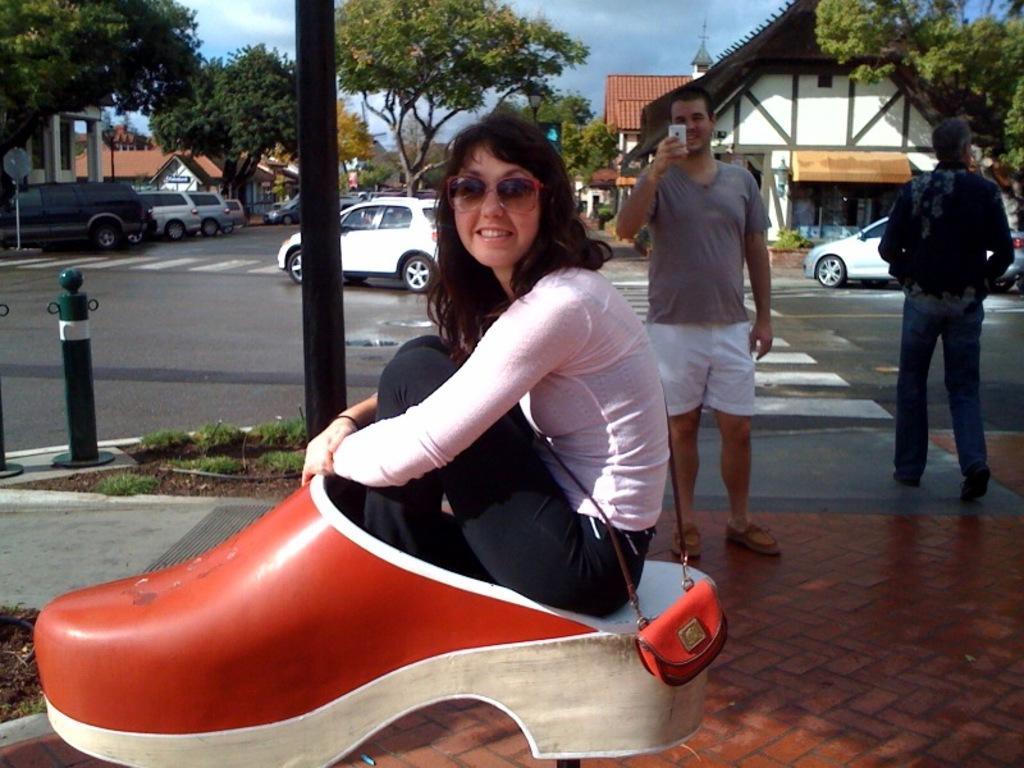In one or two sentences, can you explain what this image depicts? In this image we can see a woman. She is sitting on a shoe type structure. Behind her, we can see two men are standing on the pavement and there are cars on the road. There is a pole, some grass and green color object on the left side of the image. In the background, we can see tree and buildings. At the top of the image, we can see the sky. 